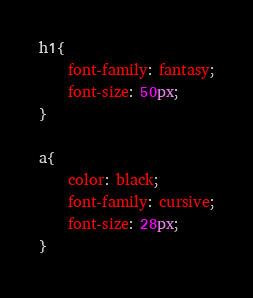<code> <loc_0><loc_0><loc_500><loc_500><_CSS_>h1{
    font-family: fantasy;
    font-size: 50px;
}

a{
    color: black;
    font-family: cursive;
    font-size: 28px;
}</code> 